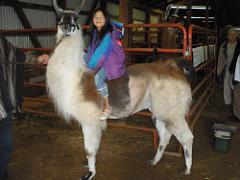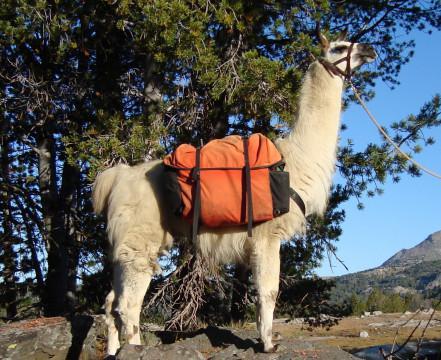The first image is the image on the left, the second image is the image on the right. For the images shown, is this caption "In at least one image there is a hunter with deer horns and  two llames." true? Answer yes or no. No. 